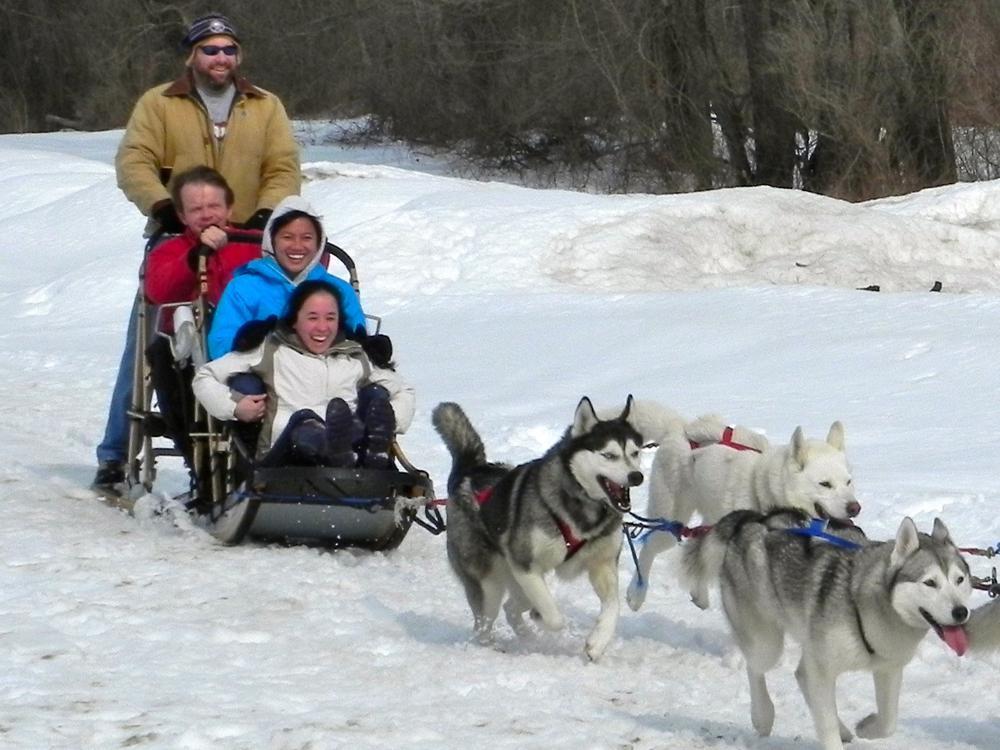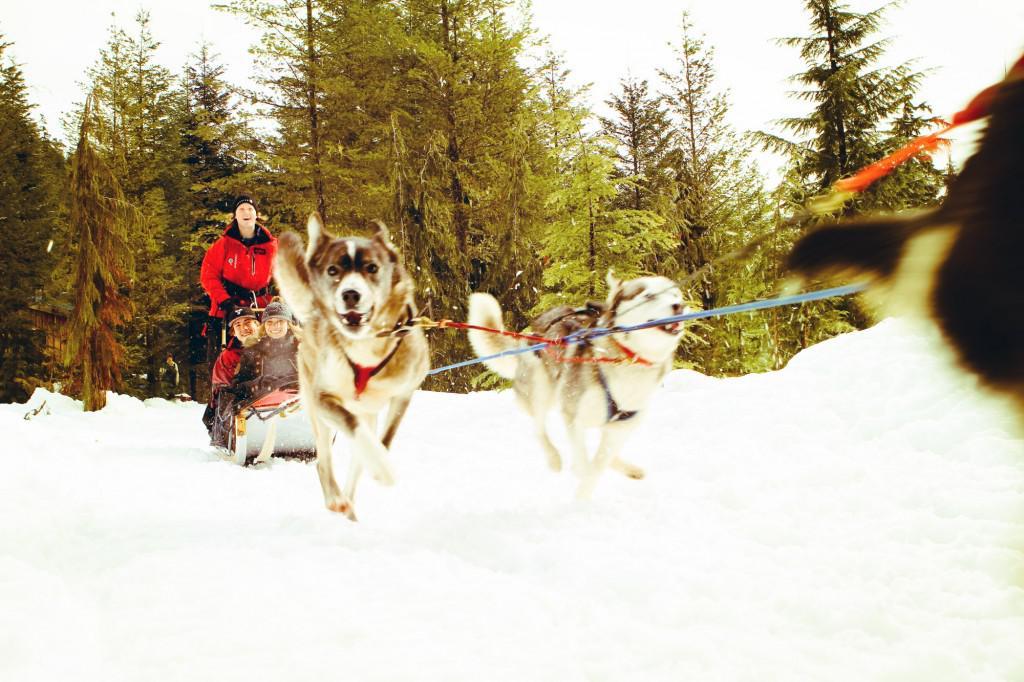The first image is the image on the left, the second image is the image on the right. Evaluate the accuracy of this statement regarding the images: "The man standing behind the sled in the image on the left is wearing a red jacket.". Is it true? Answer yes or no. No. The first image is the image on the left, the second image is the image on the right. Given the left and right images, does the statement "there is a dog sled team pulling a sled with one person standing and 3 people inside the sled" hold true? Answer yes or no. Yes. 